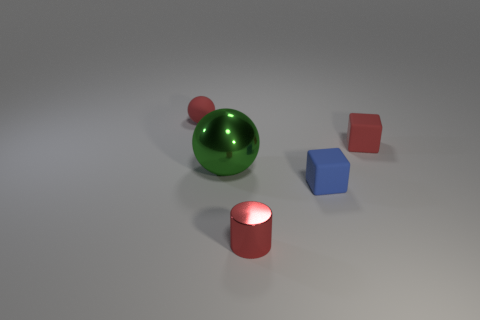Is the number of small red objects that are in front of the big green sphere greater than the number of tiny rubber things?
Provide a succinct answer. No. There is a large green shiny object; is its shape the same as the red thing that is in front of the big green metallic object?
Keep it short and to the point. No. The metal object that is the same color as the tiny sphere is what shape?
Provide a succinct answer. Cylinder. There is a tiny block that is in front of the small block behind the tiny blue cube; how many green objects are behind it?
Your answer should be compact. 1. What is the color of the rubber sphere that is the same size as the red metal cylinder?
Offer a very short reply. Red. There is a green sphere that is in front of the tiny object that is on the left side of the shiny cylinder; how big is it?
Offer a very short reply. Large. What size is the cylinder that is the same color as the tiny matte ball?
Give a very brief answer. Small. What number of other things are there of the same size as the blue rubber object?
Offer a terse response. 3. How many large balls are there?
Give a very brief answer. 1. Do the cylinder and the blue cube have the same size?
Your response must be concise. Yes. 